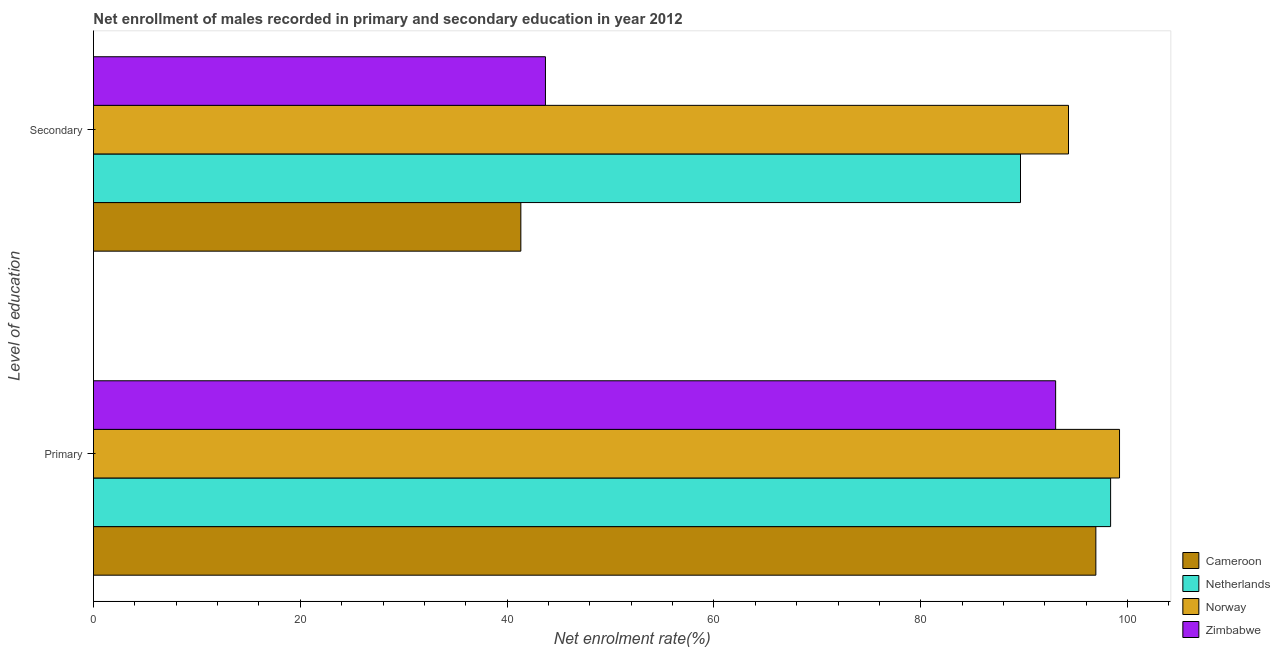How many groups of bars are there?
Give a very brief answer. 2. Are the number of bars per tick equal to the number of legend labels?
Make the answer very short. Yes. How many bars are there on the 2nd tick from the bottom?
Offer a terse response. 4. What is the label of the 1st group of bars from the top?
Ensure brevity in your answer.  Secondary. What is the enrollment rate in secondary education in Netherlands?
Your answer should be compact. 89.64. Across all countries, what is the maximum enrollment rate in secondary education?
Offer a terse response. 94.28. Across all countries, what is the minimum enrollment rate in primary education?
Offer a very short reply. 93.04. In which country was the enrollment rate in primary education maximum?
Give a very brief answer. Norway. In which country was the enrollment rate in secondary education minimum?
Keep it short and to the point. Cameroon. What is the total enrollment rate in secondary education in the graph?
Offer a terse response. 268.96. What is the difference between the enrollment rate in primary education in Netherlands and that in Cameroon?
Your answer should be very brief. 1.43. What is the difference between the enrollment rate in primary education in Norway and the enrollment rate in secondary education in Netherlands?
Give a very brief answer. 9.58. What is the average enrollment rate in primary education per country?
Make the answer very short. 96.89. What is the difference between the enrollment rate in secondary education and enrollment rate in primary education in Cameroon?
Your answer should be compact. -55.6. What is the ratio of the enrollment rate in secondary education in Netherlands to that in Zimbabwe?
Give a very brief answer. 2.05. Is the enrollment rate in secondary education in Zimbabwe less than that in Netherlands?
Provide a short and direct response. Yes. In how many countries, is the enrollment rate in secondary education greater than the average enrollment rate in secondary education taken over all countries?
Your response must be concise. 2. What does the 1st bar from the top in Primary represents?
Your answer should be very brief. Zimbabwe. What does the 4th bar from the bottom in Primary represents?
Provide a short and direct response. Zimbabwe. Are all the bars in the graph horizontal?
Keep it short and to the point. Yes. Are the values on the major ticks of X-axis written in scientific E-notation?
Your response must be concise. No. Does the graph contain grids?
Your answer should be very brief. No. Where does the legend appear in the graph?
Offer a very short reply. Bottom right. How are the legend labels stacked?
Give a very brief answer. Vertical. What is the title of the graph?
Your response must be concise. Net enrollment of males recorded in primary and secondary education in year 2012. What is the label or title of the X-axis?
Keep it short and to the point. Net enrolment rate(%). What is the label or title of the Y-axis?
Your answer should be very brief. Level of education. What is the Net enrolment rate(%) of Cameroon in Primary?
Your response must be concise. 96.93. What is the Net enrolment rate(%) of Netherlands in Primary?
Your answer should be very brief. 98.36. What is the Net enrolment rate(%) of Norway in Primary?
Provide a succinct answer. 99.22. What is the Net enrolment rate(%) in Zimbabwe in Primary?
Your response must be concise. 93.04. What is the Net enrolment rate(%) of Cameroon in Secondary?
Provide a short and direct response. 41.33. What is the Net enrolment rate(%) of Netherlands in Secondary?
Offer a very short reply. 89.64. What is the Net enrolment rate(%) in Norway in Secondary?
Your answer should be very brief. 94.28. What is the Net enrolment rate(%) in Zimbabwe in Secondary?
Provide a succinct answer. 43.71. Across all Level of education, what is the maximum Net enrolment rate(%) of Cameroon?
Offer a terse response. 96.93. Across all Level of education, what is the maximum Net enrolment rate(%) in Netherlands?
Your answer should be very brief. 98.36. Across all Level of education, what is the maximum Net enrolment rate(%) in Norway?
Offer a terse response. 99.22. Across all Level of education, what is the maximum Net enrolment rate(%) in Zimbabwe?
Offer a terse response. 93.04. Across all Level of education, what is the minimum Net enrolment rate(%) of Cameroon?
Your answer should be very brief. 41.33. Across all Level of education, what is the minimum Net enrolment rate(%) in Netherlands?
Offer a very short reply. 89.64. Across all Level of education, what is the minimum Net enrolment rate(%) of Norway?
Your response must be concise. 94.28. Across all Level of education, what is the minimum Net enrolment rate(%) of Zimbabwe?
Keep it short and to the point. 43.71. What is the total Net enrolment rate(%) in Cameroon in the graph?
Offer a very short reply. 138.26. What is the total Net enrolment rate(%) of Netherlands in the graph?
Provide a short and direct response. 188. What is the total Net enrolment rate(%) of Norway in the graph?
Your answer should be very brief. 193.5. What is the total Net enrolment rate(%) of Zimbabwe in the graph?
Provide a succinct answer. 136.75. What is the difference between the Net enrolment rate(%) in Cameroon in Primary and that in Secondary?
Your answer should be very brief. 55.6. What is the difference between the Net enrolment rate(%) in Netherlands in Primary and that in Secondary?
Your response must be concise. 8.71. What is the difference between the Net enrolment rate(%) in Norway in Primary and that in Secondary?
Offer a very short reply. 4.93. What is the difference between the Net enrolment rate(%) of Zimbabwe in Primary and that in Secondary?
Provide a short and direct response. 49.33. What is the difference between the Net enrolment rate(%) of Cameroon in Primary and the Net enrolment rate(%) of Netherlands in Secondary?
Provide a succinct answer. 7.29. What is the difference between the Net enrolment rate(%) of Cameroon in Primary and the Net enrolment rate(%) of Norway in Secondary?
Offer a very short reply. 2.65. What is the difference between the Net enrolment rate(%) of Cameroon in Primary and the Net enrolment rate(%) of Zimbabwe in Secondary?
Ensure brevity in your answer.  53.22. What is the difference between the Net enrolment rate(%) in Netherlands in Primary and the Net enrolment rate(%) in Norway in Secondary?
Give a very brief answer. 4.07. What is the difference between the Net enrolment rate(%) of Netherlands in Primary and the Net enrolment rate(%) of Zimbabwe in Secondary?
Your answer should be very brief. 54.65. What is the difference between the Net enrolment rate(%) in Norway in Primary and the Net enrolment rate(%) in Zimbabwe in Secondary?
Make the answer very short. 55.51. What is the average Net enrolment rate(%) of Cameroon per Level of education?
Your response must be concise. 69.13. What is the average Net enrolment rate(%) of Netherlands per Level of education?
Keep it short and to the point. 94. What is the average Net enrolment rate(%) of Norway per Level of education?
Make the answer very short. 96.75. What is the average Net enrolment rate(%) in Zimbabwe per Level of education?
Provide a short and direct response. 68.37. What is the difference between the Net enrolment rate(%) in Cameroon and Net enrolment rate(%) in Netherlands in Primary?
Your answer should be compact. -1.43. What is the difference between the Net enrolment rate(%) of Cameroon and Net enrolment rate(%) of Norway in Primary?
Keep it short and to the point. -2.29. What is the difference between the Net enrolment rate(%) in Cameroon and Net enrolment rate(%) in Zimbabwe in Primary?
Your response must be concise. 3.89. What is the difference between the Net enrolment rate(%) of Netherlands and Net enrolment rate(%) of Norway in Primary?
Your response must be concise. -0.86. What is the difference between the Net enrolment rate(%) of Netherlands and Net enrolment rate(%) of Zimbabwe in Primary?
Ensure brevity in your answer.  5.32. What is the difference between the Net enrolment rate(%) in Norway and Net enrolment rate(%) in Zimbabwe in Primary?
Your response must be concise. 6.18. What is the difference between the Net enrolment rate(%) of Cameroon and Net enrolment rate(%) of Netherlands in Secondary?
Provide a succinct answer. -48.32. What is the difference between the Net enrolment rate(%) in Cameroon and Net enrolment rate(%) in Norway in Secondary?
Your answer should be compact. -52.96. What is the difference between the Net enrolment rate(%) in Cameroon and Net enrolment rate(%) in Zimbabwe in Secondary?
Offer a very short reply. -2.38. What is the difference between the Net enrolment rate(%) of Netherlands and Net enrolment rate(%) of Norway in Secondary?
Make the answer very short. -4.64. What is the difference between the Net enrolment rate(%) in Netherlands and Net enrolment rate(%) in Zimbabwe in Secondary?
Provide a short and direct response. 45.94. What is the difference between the Net enrolment rate(%) of Norway and Net enrolment rate(%) of Zimbabwe in Secondary?
Keep it short and to the point. 50.58. What is the ratio of the Net enrolment rate(%) of Cameroon in Primary to that in Secondary?
Give a very brief answer. 2.35. What is the ratio of the Net enrolment rate(%) of Netherlands in Primary to that in Secondary?
Your answer should be compact. 1.1. What is the ratio of the Net enrolment rate(%) in Norway in Primary to that in Secondary?
Provide a succinct answer. 1.05. What is the ratio of the Net enrolment rate(%) in Zimbabwe in Primary to that in Secondary?
Your response must be concise. 2.13. What is the difference between the highest and the second highest Net enrolment rate(%) in Cameroon?
Give a very brief answer. 55.6. What is the difference between the highest and the second highest Net enrolment rate(%) in Netherlands?
Make the answer very short. 8.71. What is the difference between the highest and the second highest Net enrolment rate(%) in Norway?
Offer a terse response. 4.93. What is the difference between the highest and the second highest Net enrolment rate(%) of Zimbabwe?
Make the answer very short. 49.33. What is the difference between the highest and the lowest Net enrolment rate(%) in Cameroon?
Keep it short and to the point. 55.6. What is the difference between the highest and the lowest Net enrolment rate(%) of Netherlands?
Offer a very short reply. 8.71. What is the difference between the highest and the lowest Net enrolment rate(%) in Norway?
Give a very brief answer. 4.93. What is the difference between the highest and the lowest Net enrolment rate(%) in Zimbabwe?
Offer a very short reply. 49.33. 